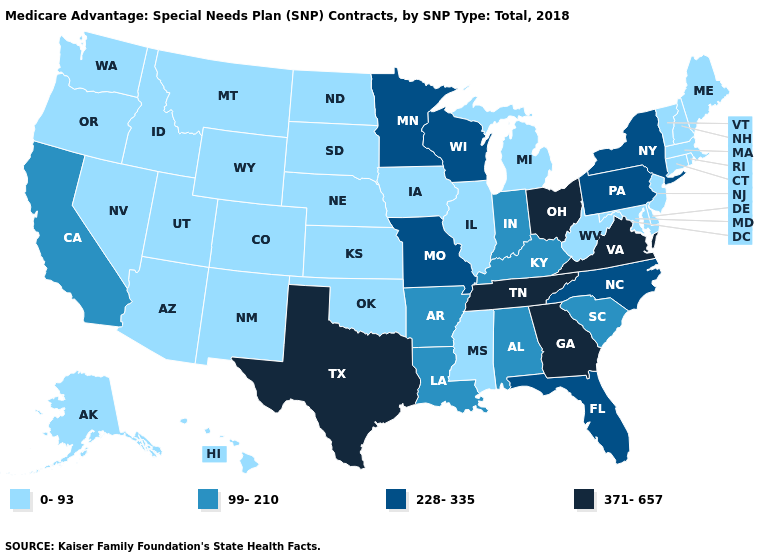Name the states that have a value in the range 0-93?
Be succinct. Alaska, Arizona, Colorado, Connecticut, Delaware, Hawaii, Iowa, Idaho, Illinois, Kansas, Massachusetts, Maryland, Maine, Michigan, Mississippi, Montana, North Dakota, Nebraska, New Hampshire, New Jersey, New Mexico, Nevada, Oklahoma, Oregon, Rhode Island, South Dakota, Utah, Vermont, Washington, West Virginia, Wyoming. Name the states that have a value in the range 0-93?
Answer briefly. Alaska, Arizona, Colorado, Connecticut, Delaware, Hawaii, Iowa, Idaho, Illinois, Kansas, Massachusetts, Maryland, Maine, Michigan, Mississippi, Montana, North Dakota, Nebraska, New Hampshire, New Jersey, New Mexico, Nevada, Oklahoma, Oregon, Rhode Island, South Dakota, Utah, Vermont, Washington, West Virginia, Wyoming. What is the lowest value in the USA?
Write a very short answer. 0-93. Which states have the highest value in the USA?
Answer briefly. Georgia, Ohio, Tennessee, Texas, Virginia. Does Hawaii have the same value as Massachusetts?
Give a very brief answer. Yes. Does the map have missing data?
Concise answer only. No. Does Ohio have the highest value in the MidWest?
Write a very short answer. Yes. Name the states that have a value in the range 228-335?
Quick response, please. Florida, Minnesota, Missouri, North Carolina, New York, Pennsylvania, Wisconsin. Name the states that have a value in the range 371-657?
Write a very short answer. Georgia, Ohio, Tennessee, Texas, Virginia. Does Maine have a lower value than Indiana?
Be succinct. Yes. What is the value of Maine?
Be succinct. 0-93. Name the states that have a value in the range 371-657?
Concise answer only. Georgia, Ohio, Tennessee, Texas, Virginia. Does the first symbol in the legend represent the smallest category?
Short answer required. Yes. What is the value of Washington?
Be succinct. 0-93. Does the first symbol in the legend represent the smallest category?
Keep it brief. Yes. 